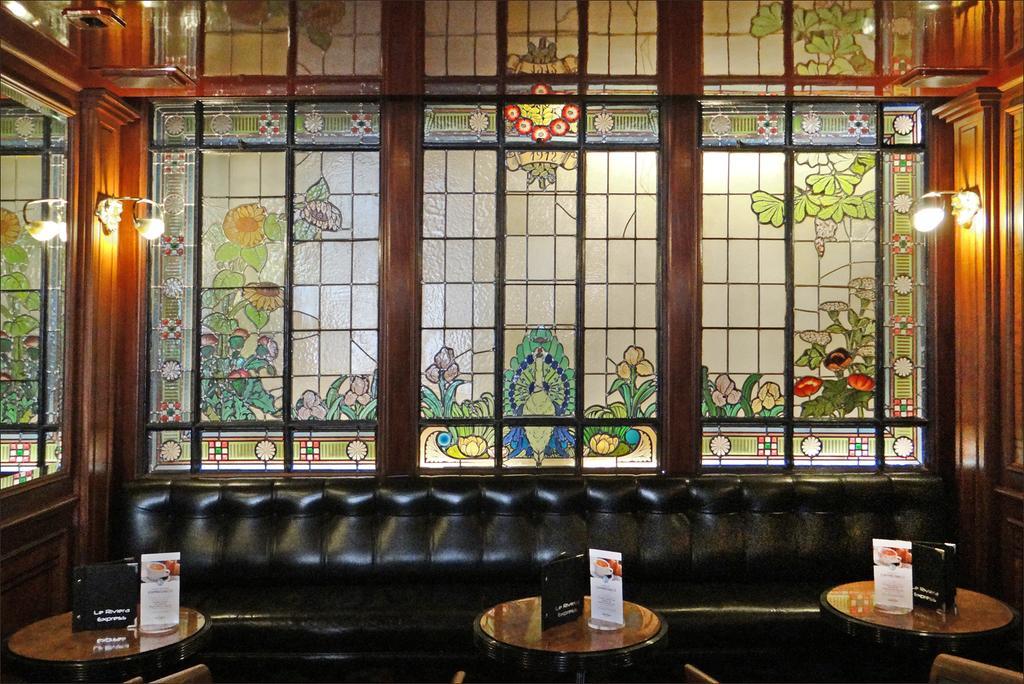Please provide a concise description of this image. In this image we can see black color sofa. In front of the sofa tables are there. On table pamphlet are present. Behind the sofa glass windows colorful painting are present. To the both sides of the image lights are there. 